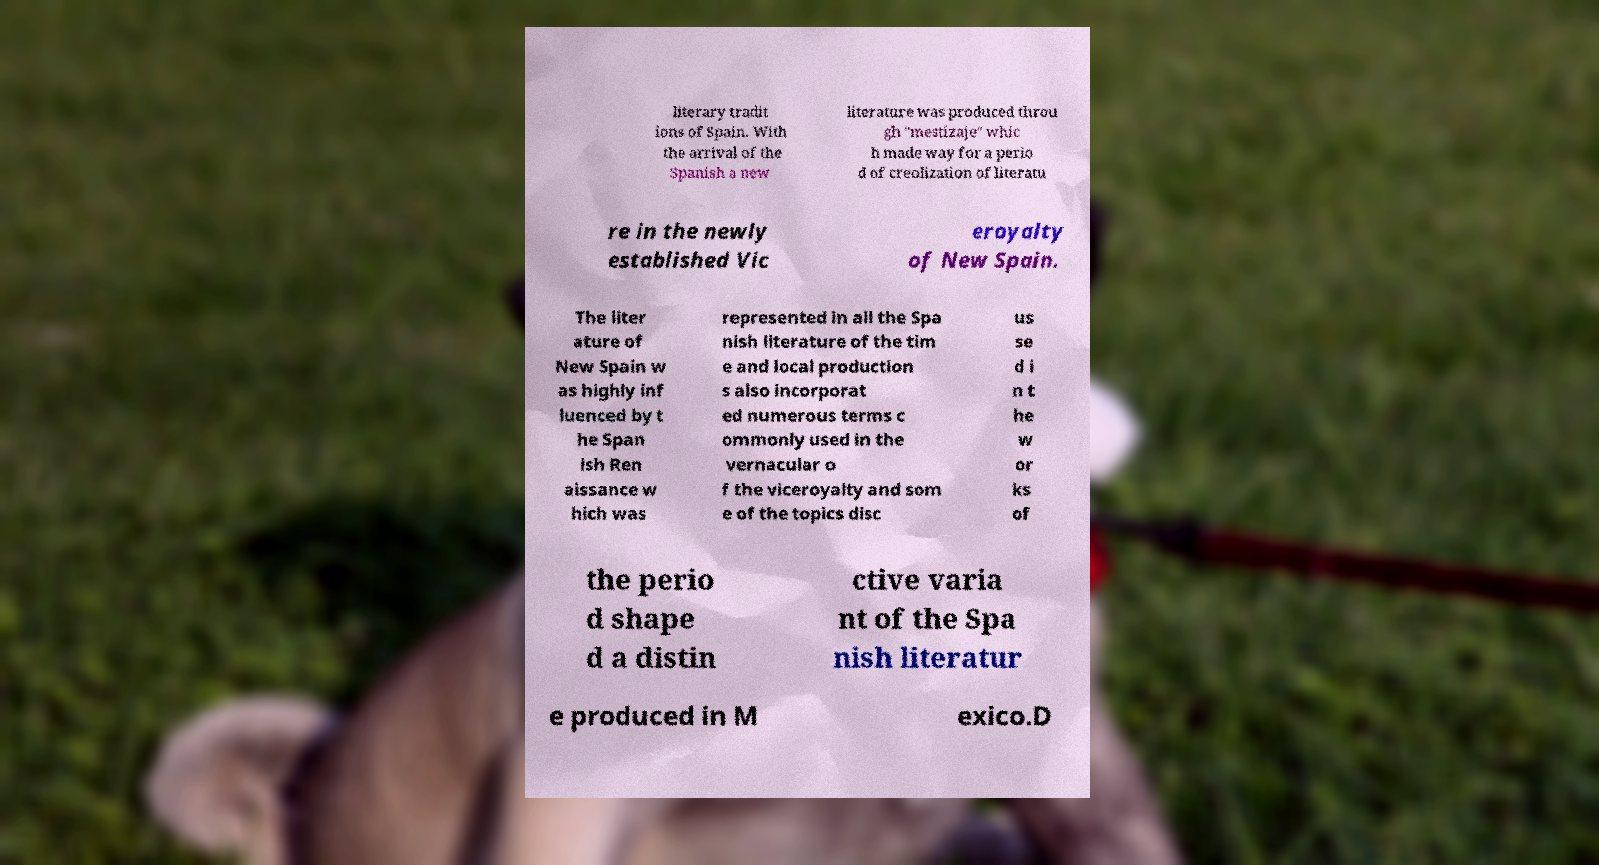Could you extract and type out the text from this image? literary tradit ions of Spain. With the arrival of the Spanish a new literature was produced throu gh "mestizaje" whic h made way for a perio d of creolization of literatu re in the newly established Vic eroyalty of New Spain. The liter ature of New Spain w as highly inf luenced by t he Span ish Ren aissance w hich was represented in all the Spa nish literature of the tim e and local production s also incorporat ed numerous terms c ommonly used in the vernacular o f the viceroyalty and som e of the topics disc us se d i n t he w or ks of the perio d shape d a distin ctive varia nt of the Spa nish literatur e produced in M exico.D 